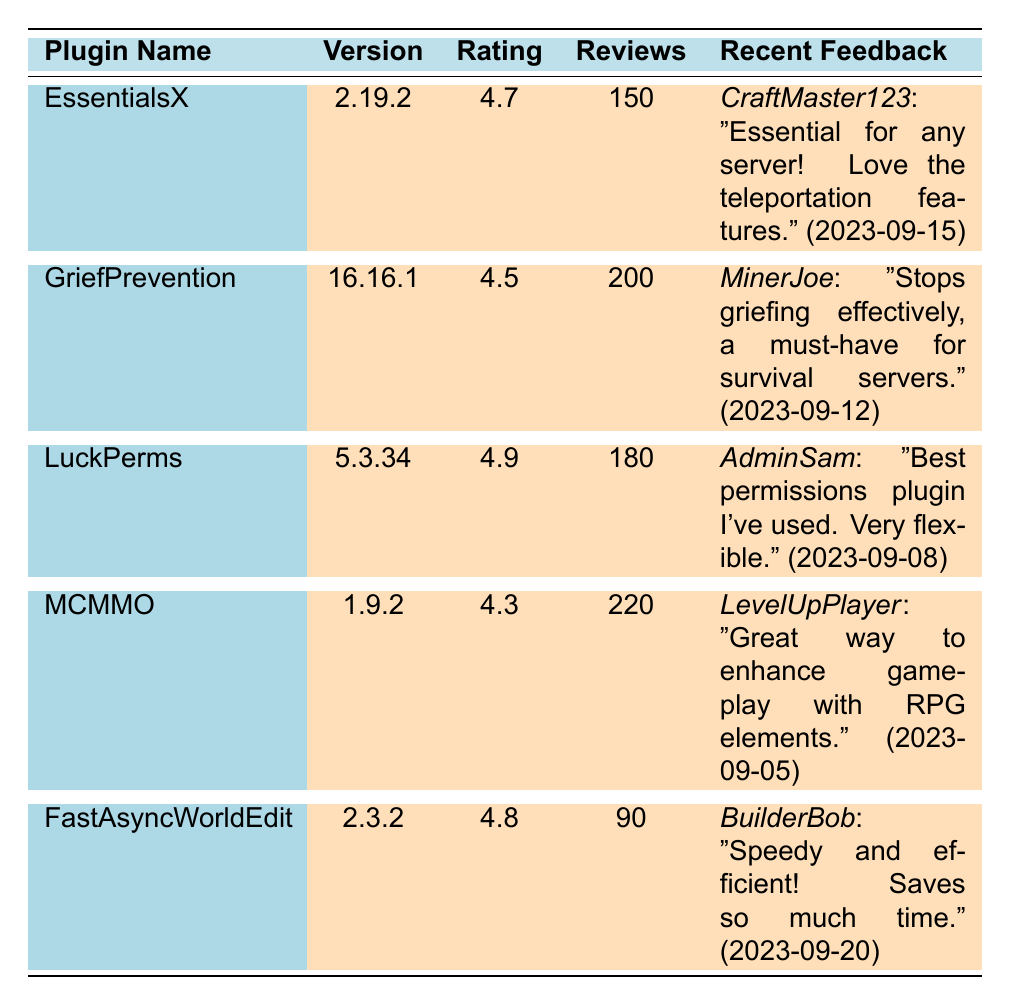What is the rating of the LuckPerms plugin? The rating for LuckPerms is explicitly listed in the table under the "Rating" column, where it shows 4.9.
Answer: 4.9 Which plugin has the highest number of reviews? By examining the "Reviews" column, MCMMO has the highest number of reviews at 220.
Answer: MCMMO What is the average rating of the plugins listed? To calculate the average rating, we sum the ratings (4.7 + 4.5 + 4.9 + 4.3 + 4.8 = 24.2) and divide by the number of plugins (5), resulting in 24.2 / 5 = 4.84.
Answer: 4.84 Is the rating of the FastAsyncWorldEdit plugin greater than the rating of MCMMO? FastAsyncWorldEdit has a rating of 4.8, and MCMMO has a rating of 4.3; since 4.8 is greater than 4.3, the statement is true.
Answer: Yes How many more reviews does GriefPrevention have than EssentialsX? GriefPrevention has 200 reviews while EssentialsX has 150 reviews; calculating the difference (200 - 150) gives us 50.
Answer: 50 Which plugin has the most recent feedback date? The recent feedback for FastAsyncWorldEdit is dated 2023-09-20, which is the latest date compared to others in the table.
Answer: FastAsyncWorldEdit What is the difference in rating between LuckPerms and MCMMO? LuckPerms has a rating of 4.9, and MCMMO has a rating of 4.3; subtracting these values (4.9 - 4.3) gives us 0.6.
Answer: 0.6 Does any plugin have a rating of 4.5 or lower? GriefPrevention has a rating of 4.5 and MCMMO has a rating of 4.3; therefore, the answer to whether any plugin has a rating of 4.5 or lower is yes.
Answer: Yes What percentage of reviews for the LuckPerms plugin are positive, given its rating of 4.9? Assuming the rating is out of 5, the percentage of positive reviews can be calculated as (4.9 / 5) * 100 = 98%.
Answer: 98% Which plugin is characterized by mostly positive feedback and why? LuckPerms is characterized by mostly positive feedback, with a high rating of 4.9 and favorable comments about flexibility and ease of setup.
Answer: LuckPerms How does the average number of reviews compare between plugins with a rating above 4.5 and those with 4.5 or below? The average for plugins above 4.5 (EssentialsX, LuckPerms, FastAsyncWorldEdit) is (150 + 180 + 90)/3 = 140. The average for 4.5 or below (GriefPrevention, MCMMO) is (200 + 220)/2 = 210. Therefore, 140 is less than 210.
Answer: 140 is less than 210 